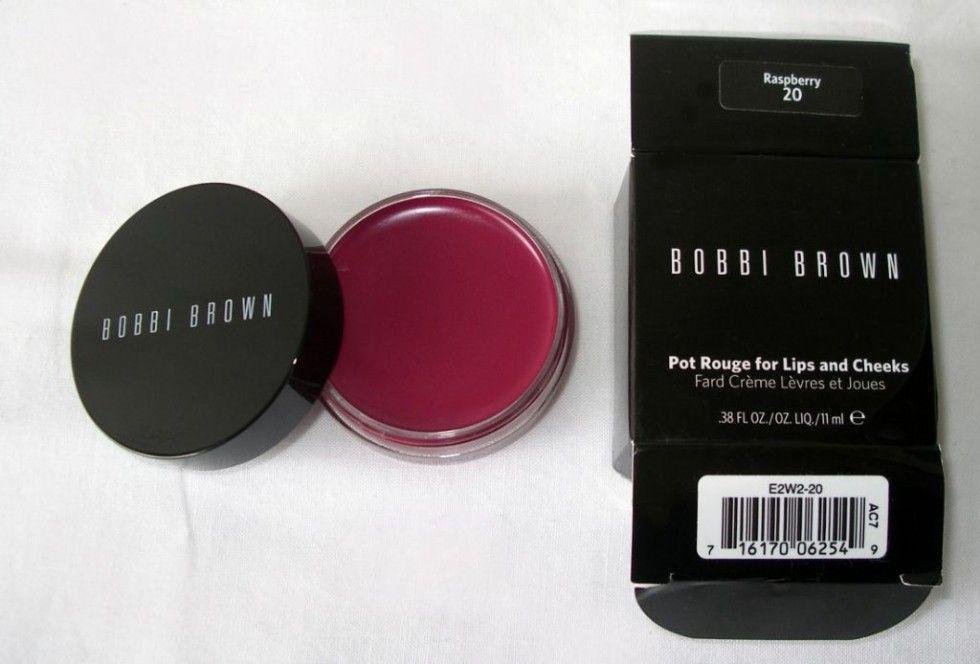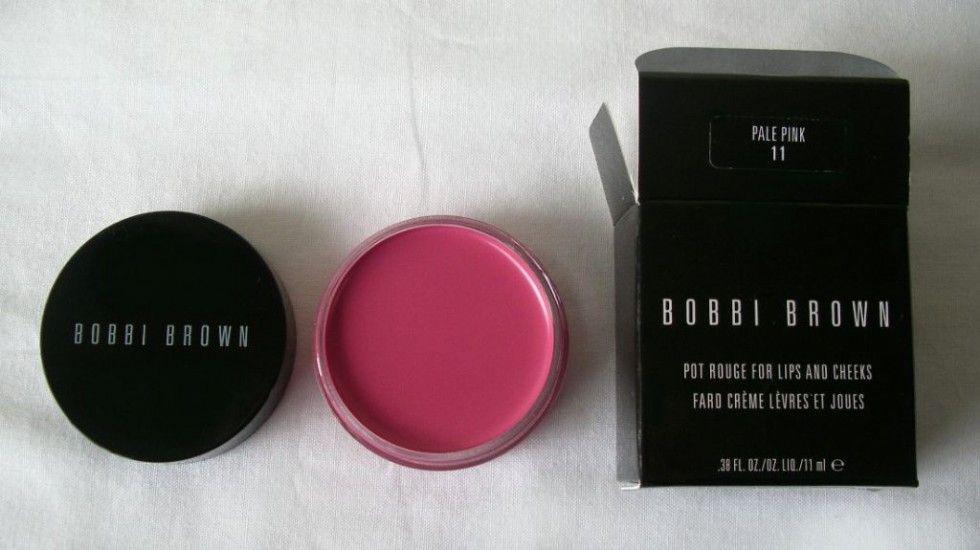The first image is the image on the left, the second image is the image on the right. Analyze the images presented: Is the assertion "In one of the images the makeup is sitting upon a wooden surface." valid? Answer yes or no. No. The first image is the image on the left, the second image is the image on the right. Considering the images on both sides, is "One image shows one opened pot of pink rouge sitting on a wood-look surface." valid? Answer yes or no. No. 